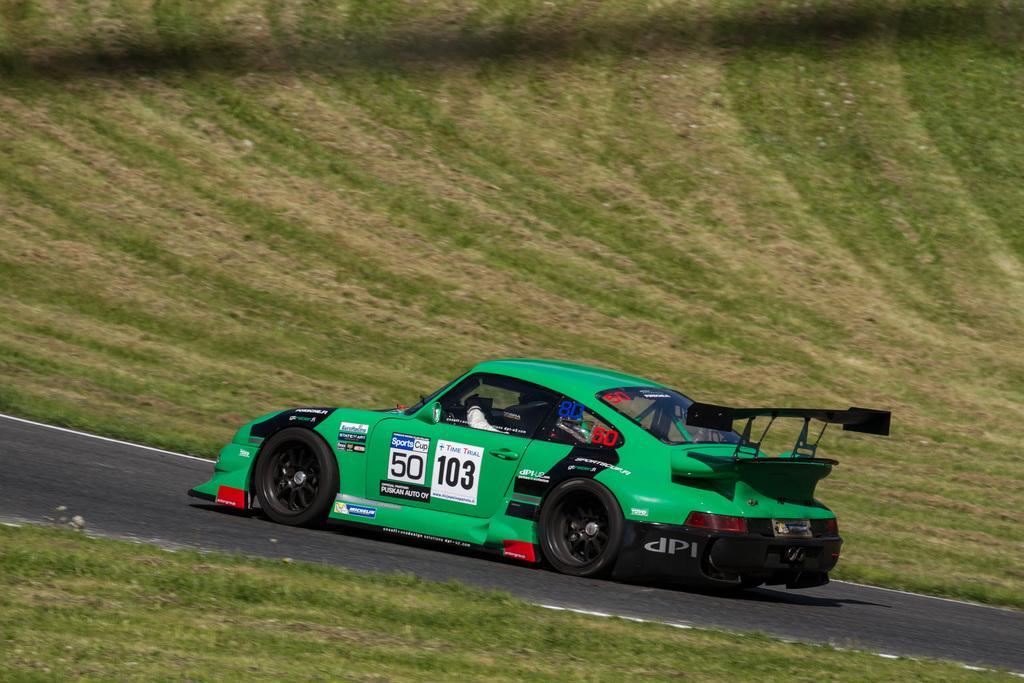How would you summarize this image in a sentence or two? In this image I can see a vehicle which is in green color and the vehicle is on the road. Background I can see the grass in green color. 